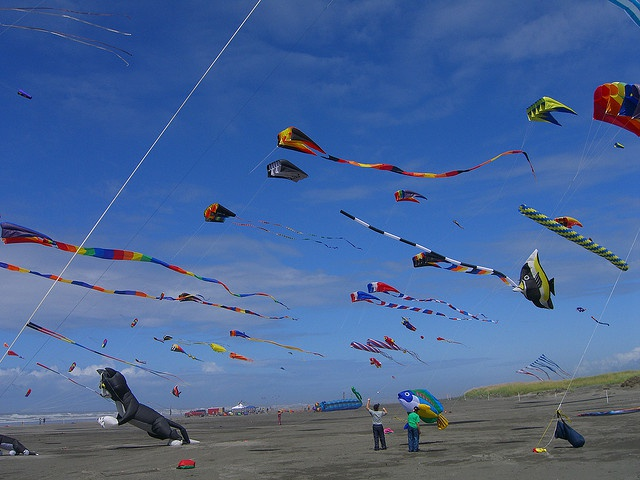Describe the objects in this image and their specific colors. I can see kite in blue and gray tones, kite in blue, gray, navy, and maroon tones, kite in blue, gray, darkgray, and navy tones, kite in blue, black, darkgray, and gray tones, and kite in blue, maroon, black, and navy tones in this image. 